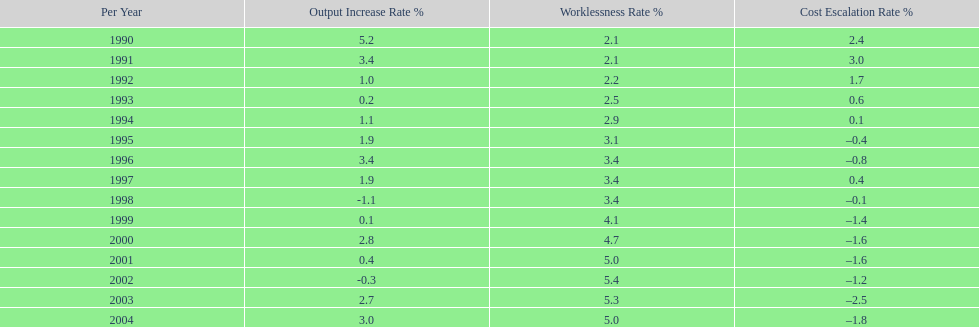What year saw the highest output growth rate in japan between the years 1990 and 2004? 1990. 